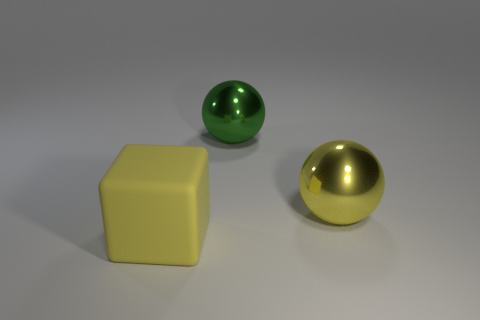Add 3 big green metal spheres. How many objects exist? 6 Subtract all yellow spheres. How many spheres are left? 1 Subtract all spheres. How many objects are left? 1 Subtract 2 balls. How many balls are left? 0 Add 1 large green things. How many large green things are left? 2 Add 1 big matte objects. How many big matte objects exist? 2 Subtract 1 green balls. How many objects are left? 2 Subtract all green spheres. Subtract all blue cylinders. How many spheres are left? 1 Subtract all yellow cubes. How many yellow balls are left? 1 Subtract all large metal spheres. Subtract all blocks. How many objects are left? 0 